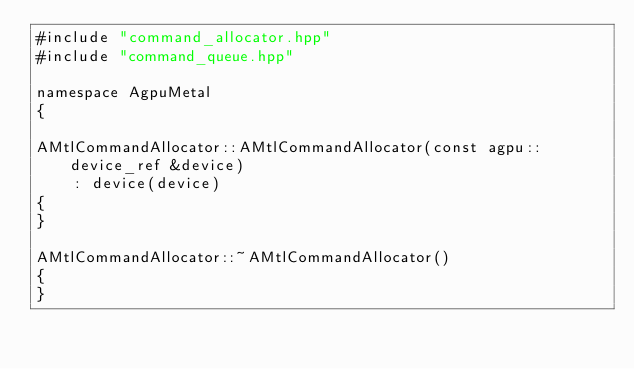<code> <loc_0><loc_0><loc_500><loc_500><_ObjectiveC_>#include "command_allocator.hpp"
#include "command_queue.hpp"

namespace AgpuMetal
{
    
AMtlCommandAllocator::AMtlCommandAllocator(const agpu::device_ref &device)
    : device(device)
{
}

AMtlCommandAllocator::~AMtlCommandAllocator()
{
}
</code> 